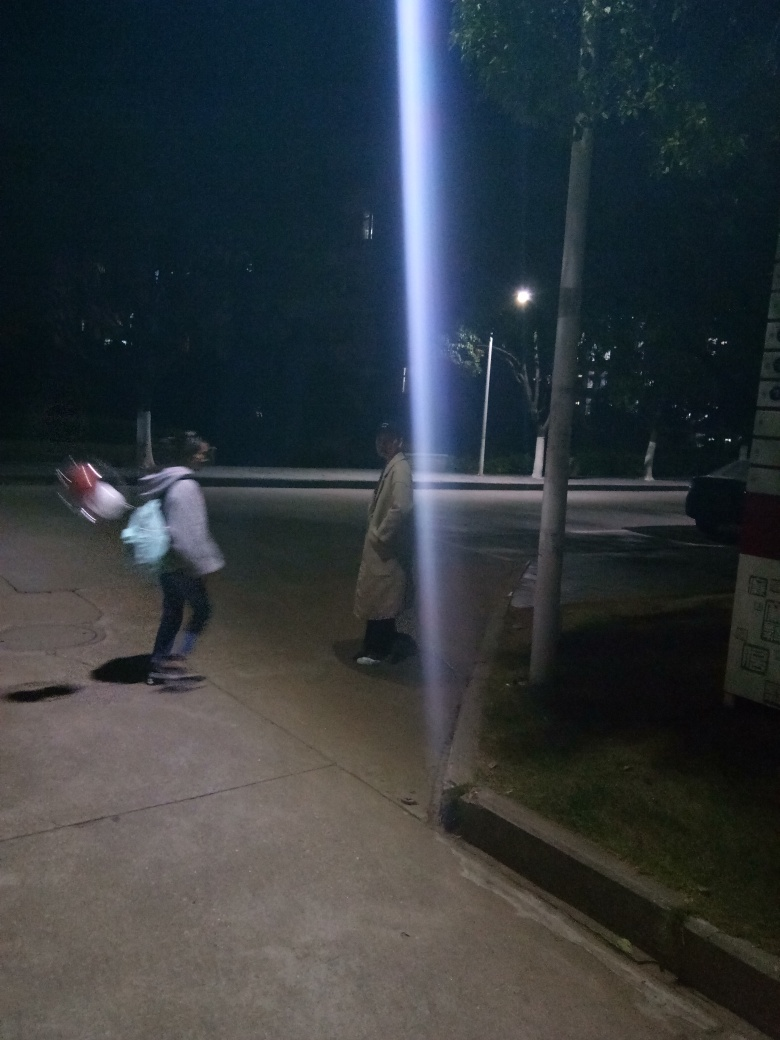Is the main subject, a pedestrian, very blurry and lacking texture details? The pedestrian in the image does appear blurry with motion blur present, this suggests movement and a low-light setting. The lack of texture detail on the pedestrian is a consequence of the photo's conditions and exposure time. 